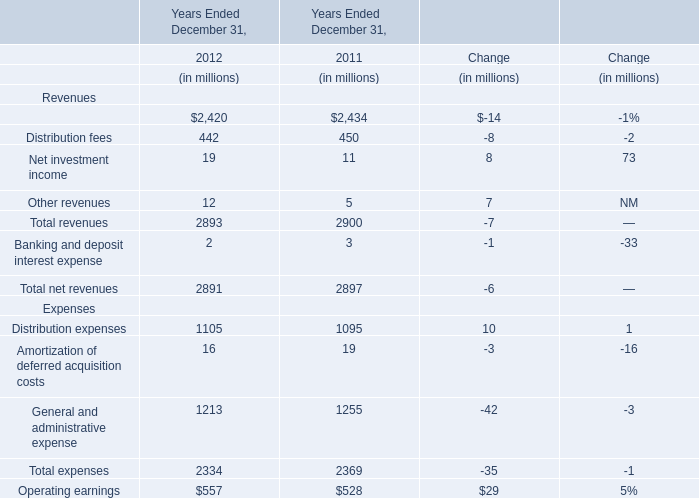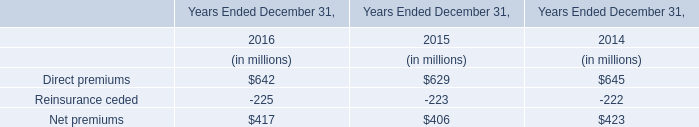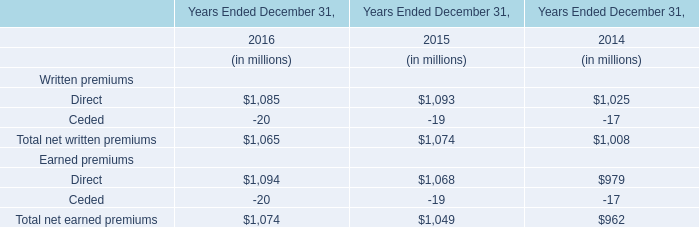In which year the Management and financial advice fees is positive? 
Answer: 2011. 